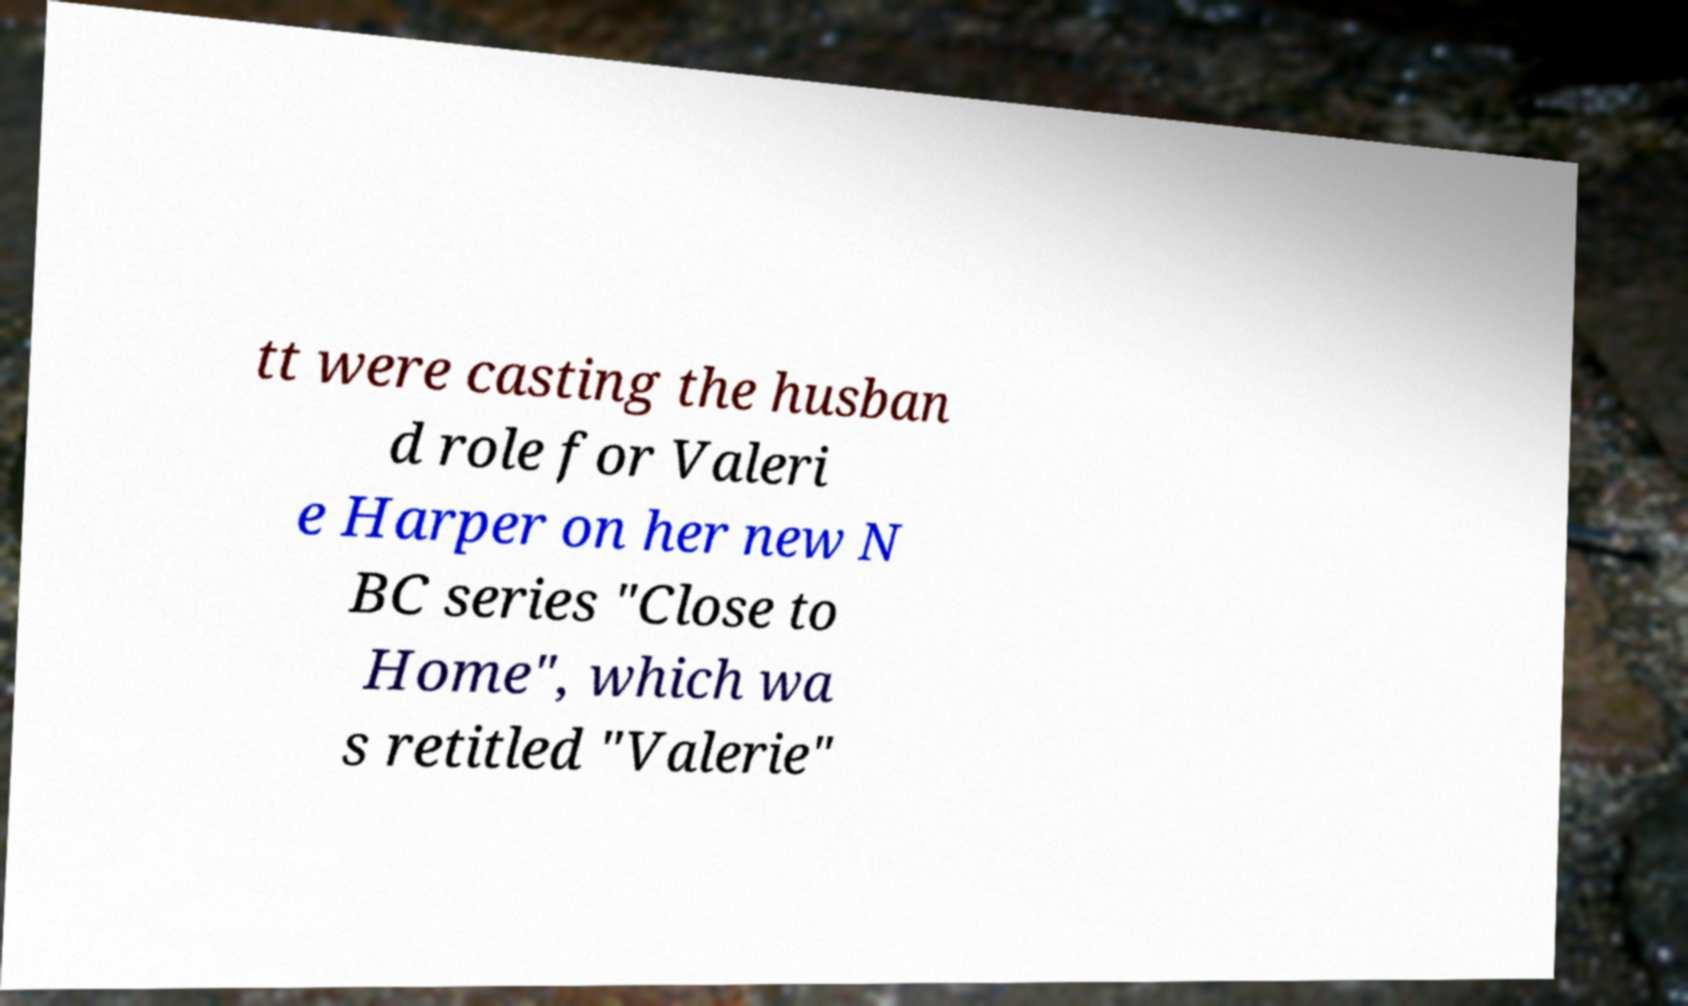There's text embedded in this image that I need extracted. Can you transcribe it verbatim? tt were casting the husban d role for Valeri e Harper on her new N BC series "Close to Home", which wa s retitled "Valerie" 